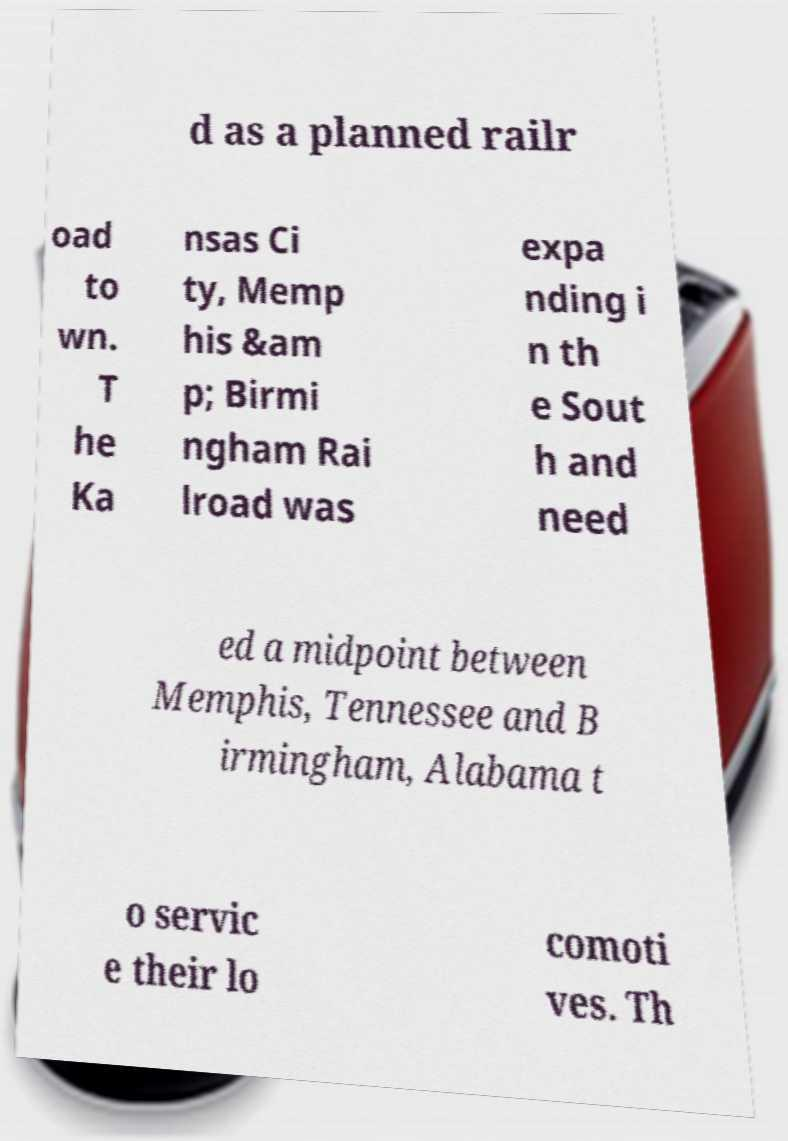Please read and relay the text visible in this image. What does it say? d as a planned railr oad to wn. T he Ka nsas Ci ty, Memp his &am p; Birmi ngham Rai lroad was expa nding i n th e Sout h and need ed a midpoint between Memphis, Tennessee and B irmingham, Alabama t o servic e their lo comoti ves. Th 